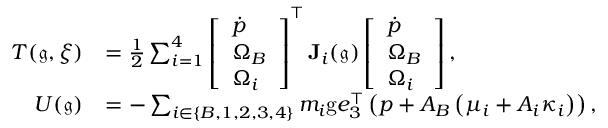Convert formula to latex. <formula><loc_0><loc_0><loc_500><loc_500>\begin{array} { r l } { T ( \mathfrak { g } , \xi ) } & { = \frac { 1 } { 2 } \sum _ { i = 1 } ^ { 4 } \left [ \begin{array} { l } { \dot { p } } \\ { \Omega _ { B } } \\ { \Omega _ { i } } \end{array} \right ] ^ { \top } J _ { i } ( \mathfrak { g } ) \left [ \begin{array} { l } { \dot { p } } \\ { \Omega _ { B } } \\ { \Omega _ { i } } \end{array} \right ] , } \\ { U ( \mathfrak { g } ) } & { = - \sum _ { i \in \{ B , 1 , 2 , 3 , 4 \} } m _ { i } g e _ { 3 } ^ { \top } \left ( p + A _ { B } \left ( \mu _ { i } + A _ { i } \kappa _ { i } \right ) \right ) , } \end{array}</formula> 